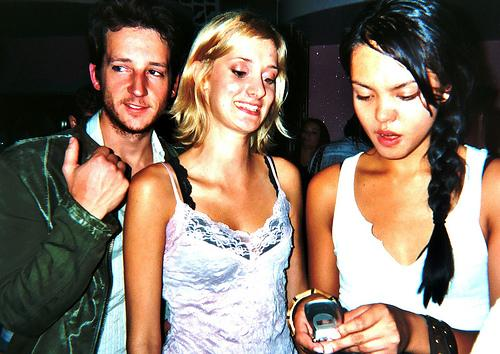Identify a piece of jewelry that one of the girls is wearing in the image. One of the girls is wearing a wooden bracelet, which adds a touch of natural and earthy style to her outfit. What are the two women in the image doing with their cell phones? One girl is looking at her own phone, sending a text message, and the other girl is looking at her friend's phone with a curious expression. Analyze the image and give a brief overview of what these friends might be doing together. One guy and two girls are hanging out together, engaging in a casual and friendly conversation while looking at their phones, sharing moments and experiences. In terms of sentiment, how would you describe the overall atmosphere depicted in the image? The overall atmosphere in the image appears relaxed, friendly, and social, with the three friends sharing a casual and engaging time together. How would you describe the hairstyle of the woman with black hair? The woman with black hair has a braid in her hair, which gives her a stylish and put-together appearance. Perform a visual analysis to identify an anomaly or something unusual in the image. One possible anomaly in the image is the presence of a starry sky outside a window, which could be unusual given the indoor, casual setting where friends are hanging out together. What can you deduce about the connection between the people in the image? The three people in the image - one guy and two girls - seem to be friends hanging out together, sharing some light moments and bonding over conversations or phone interactions. What type of top is one of the girls wearing, and what are some details about its style? One of the girls is wearing a white lace cami or tank top with a black lace strap, giving it a feminine and delicate look. Can you identify the color and type of the jacket the man in the image is wearing? The man is wearing a green jacket that looks like a casual or outdoorsy style. 